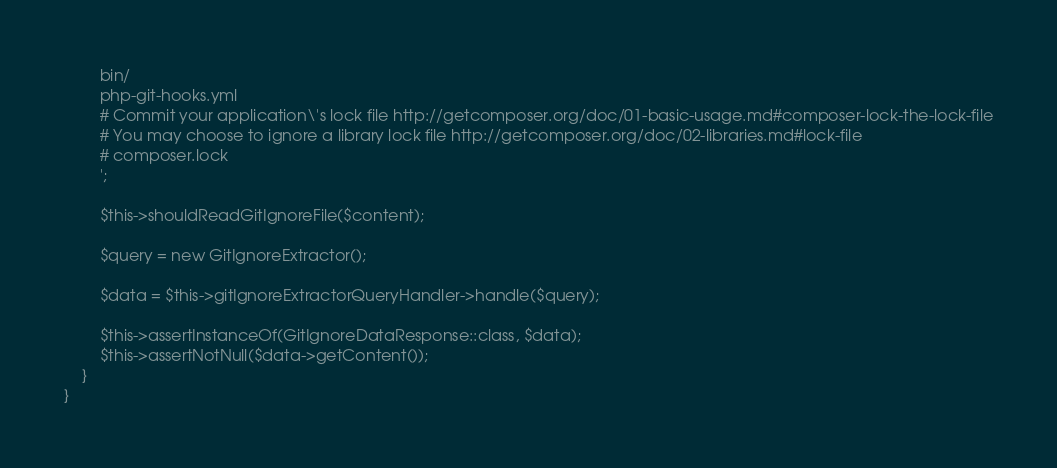Convert code to text. <code><loc_0><loc_0><loc_500><loc_500><_PHP_>        bin/
        php-git-hooks.yml
        # Commit your application\'s lock file http://getcomposer.org/doc/01-basic-usage.md#composer-lock-the-lock-file
        # You may choose to ignore a library lock file http://getcomposer.org/doc/02-libraries.md#lock-file
        # composer.lock
        ';

        $this->shouldReadGitIgnoreFile($content);

        $query = new GitIgnoreExtractor();

        $data = $this->gitIgnoreExtractorQueryHandler->handle($query);

        $this->assertInstanceOf(GitIgnoreDataResponse::class, $data);
        $this->assertNotNull($data->getContent());
    }
}
</code> 